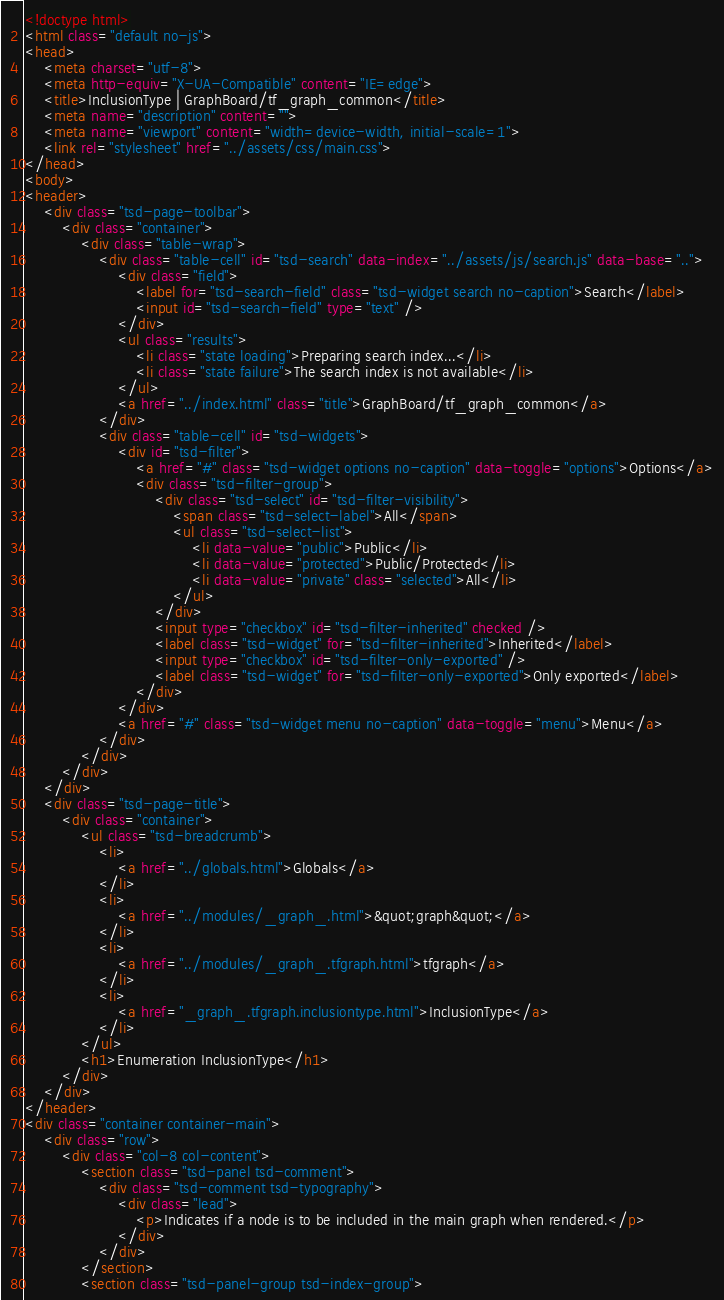<code> <loc_0><loc_0><loc_500><loc_500><_HTML_><!doctype html>
<html class="default no-js">
<head>
	<meta charset="utf-8">
	<meta http-equiv="X-UA-Compatible" content="IE=edge">
	<title>InclusionType | GraphBoard/tf_graph_common</title>
	<meta name="description" content="">
	<meta name="viewport" content="width=device-width, initial-scale=1">
	<link rel="stylesheet" href="../assets/css/main.css">
</head>
<body>
<header>
	<div class="tsd-page-toolbar">
		<div class="container">
			<div class="table-wrap">
				<div class="table-cell" id="tsd-search" data-index="../assets/js/search.js" data-base="..">
					<div class="field">
						<label for="tsd-search-field" class="tsd-widget search no-caption">Search</label>
						<input id="tsd-search-field" type="text" />
					</div>
					<ul class="results">
						<li class="state loading">Preparing search index...</li>
						<li class="state failure">The search index is not available</li>
					</ul>
					<a href="../index.html" class="title">GraphBoard/tf_graph_common</a>
				</div>
				<div class="table-cell" id="tsd-widgets">
					<div id="tsd-filter">
						<a href="#" class="tsd-widget options no-caption" data-toggle="options">Options</a>
						<div class="tsd-filter-group">
							<div class="tsd-select" id="tsd-filter-visibility">
								<span class="tsd-select-label">All</span>
								<ul class="tsd-select-list">
									<li data-value="public">Public</li>
									<li data-value="protected">Public/Protected</li>
									<li data-value="private" class="selected">All</li>
								</ul>
							</div>
							<input type="checkbox" id="tsd-filter-inherited" checked />
							<label class="tsd-widget" for="tsd-filter-inherited">Inherited</label>
							<input type="checkbox" id="tsd-filter-only-exported" />
							<label class="tsd-widget" for="tsd-filter-only-exported">Only exported</label>
						</div>
					</div>
					<a href="#" class="tsd-widget menu no-caption" data-toggle="menu">Menu</a>
				</div>
			</div>
		</div>
	</div>
	<div class="tsd-page-title">
		<div class="container">
			<ul class="tsd-breadcrumb">
				<li>
					<a href="../globals.html">Globals</a>
				</li>
				<li>
					<a href="../modules/_graph_.html">&quot;graph&quot;</a>
				</li>
				<li>
					<a href="../modules/_graph_.tfgraph.html">tfgraph</a>
				</li>
				<li>
					<a href="_graph_.tfgraph.inclusiontype.html">InclusionType</a>
				</li>
			</ul>
			<h1>Enumeration InclusionType</h1>
		</div>
	</div>
</header>
<div class="container container-main">
	<div class="row">
		<div class="col-8 col-content">
			<section class="tsd-panel tsd-comment">
				<div class="tsd-comment tsd-typography">
					<div class="lead">
						<p>Indicates if a node is to be included in the main graph when rendered.</p>
					</div>
				</div>
			</section>
			<section class="tsd-panel-group tsd-index-group"></code> 